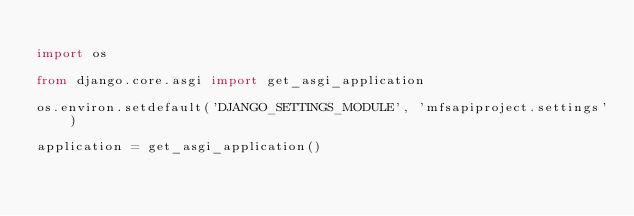Convert code to text. <code><loc_0><loc_0><loc_500><loc_500><_Python_>
import os

from django.core.asgi import get_asgi_application

os.environ.setdefault('DJANGO_SETTINGS_MODULE', 'mfsapiproject.settings')

application = get_asgi_application()
</code> 